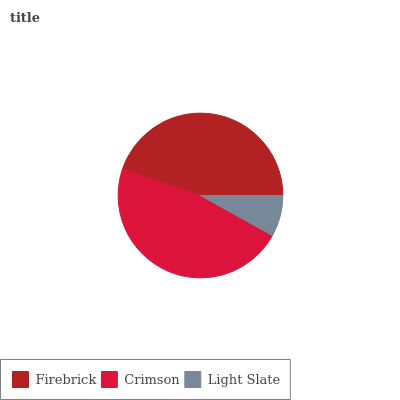Is Light Slate the minimum?
Answer yes or no. Yes. Is Crimson the maximum?
Answer yes or no. Yes. Is Crimson the minimum?
Answer yes or no. No. Is Light Slate the maximum?
Answer yes or no. No. Is Crimson greater than Light Slate?
Answer yes or no. Yes. Is Light Slate less than Crimson?
Answer yes or no. Yes. Is Light Slate greater than Crimson?
Answer yes or no. No. Is Crimson less than Light Slate?
Answer yes or no. No. Is Firebrick the high median?
Answer yes or no. Yes. Is Firebrick the low median?
Answer yes or no. Yes. Is Light Slate the high median?
Answer yes or no. No. Is Crimson the low median?
Answer yes or no. No. 